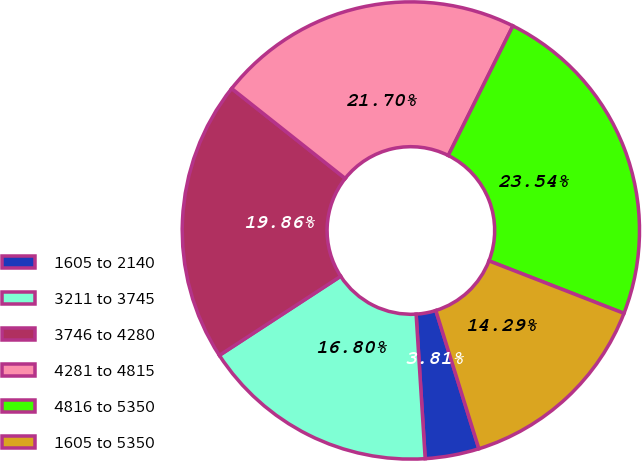Convert chart. <chart><loc_0><loc_0><loc_500><loc_500><pie_chart><fcel>1605 to 2140<fcel>3211 to 3745<fcel>3746 to 4280<fcel>4281 to 4815<fcel>4816 to 5350<fcel>1605 to 5350<nl><fcel>3.81%<fcel>16.8%<fcel>19.86%<fcel>21.7%<fcel>23.54%<fcel>14.29%<nl></chart> 